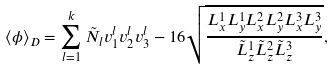Convert formula to latex. <formula><loc_0><loc_0><loc_500><loc_500>\langle \phi \rangle _ { D } = \sum _ { l = 1 } ^ { k } \tilde { N } _ { l } v _ { 1 } ^ { l } v _ { 2 } ^ { l } v _ { 3 } ^ { l } - 1 6 \sqrt { \frac { { L _ { x } ^ { 1 } } { L _ { y } ^ { 1 } } { L _ { x } ^ { 2 } } { L _ { y } ^ { 2 } } { L _ { x } ^ { 3 } } { L _ { y } ^ { 3 } } } { \tilde { L } _ { z } ^ { 1 } \tilde { L } _ { z } ^ { 2 } \tilde { L } _ { z } ^ { 3 } } } ,</formula> 